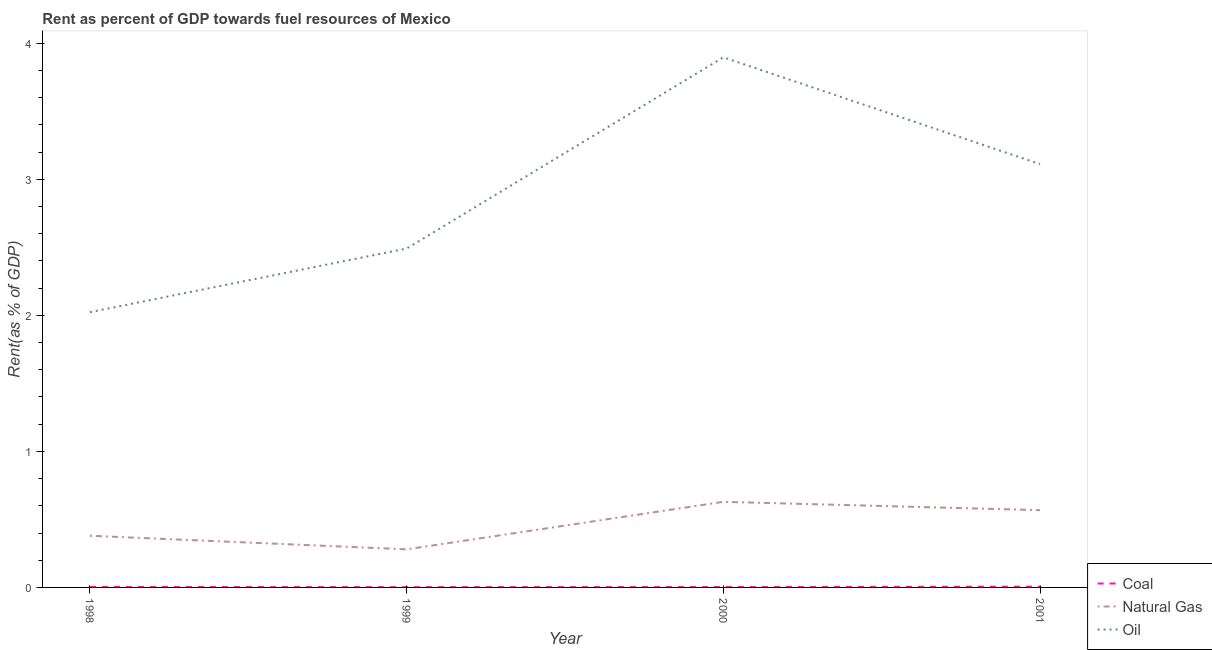Does the line corresponding to rent towards natural gas intersect with the line corresponding to rent towards oil?
Ensure brevity in your answer.  No. What is the rent towards oil in 2001?
Your answer should be very brief. 3.11. Across all years, what is the maximum rent towards oil?
Give a very brief answer. 3.9. Across all years, what is the minimum rent towards oil?
Keep it short and to the point. 2.02. In which year was the rent towards natural gas minimum?
Make the answer very short. 1999. What is the total rent towards coal in the graph?
Give a very brief answer. 0.01. What is the difference between the rent towards coal in 1999 and that in 2001?
Make the answer very short. -0. What is the difference between the rent towards natural gas in 1998 and the rent towards oil in 2000?
Give a very brief answer. -3.52. What is the average rent towards coal per year?
Offer a very short reply. 0. In the year 2000, what is the difference between the rent towards coal and rent towards oil?
Give a very brief answer. -3.89. In how many years, is the rent towards oil greater than 1.6 %?
Offer a very short reply. 4. What is the ratio of the rent towards natural gas in 2000 to that in 2001?
Offer a terse response. 1.11. Is the difference between the rent towards oil in 1998 and 2000 greater than the difference between the rent towards natural gas in 1998 and 2000?
Your answer should be very brief. No. What is the difference between the highest and the second highest rent towards natural gas?
Ensure brevity in your answer.  0.06. What is the difference between the highest and the lowest rent towards natural gas?
Your answer should be compact. 0.35. Is it the case that in every year, the sum of the rent towards coal and rent towards natural gas is greater than the rent towards oil?
Your answer should be very brief. No. Does the rent towards oil monotonically increase over the years?
Your response must be concise. No. Is the rent towards oil strictly less than the rent towards coal over the years?
Offer a terse response. No. How many years are there in the graph?
Keep it short and to the point. 4. Does the graph contain grids?
Provide a short and direct response. No. How many legend labels are there?
Your answer should be very brief. 3. How are the legend labels stacked?
Provide a succinct answer. Vertical. What is the title of the graph?
Ensure brevity in your answer.  Rent as percent of GDP towards fuel resources of Mexico. What is the label or title of the Y-axis?
Make the answer very short. Rent(as % of GDP). What is the Rent(as % of GDP) in Coal in 1998?
Offer a very short reply. 0. What is the Rent(as % of GDP) in Natural Gas in 1998?
Your answer should be very brief. 0.38. What is the Rent(as % of GDP) of Oil in 1998?
Make the answer very short. 2.02. What is the Rent(as % of GDP) of Coal in 1999?
Your answer should be compact. 0. What is the Rent(as % of GDP) of Natural Gas in 1999?
Your response must be concise. 0.28. What is the Rent(as % of GDP) of Oil in 1999?
Offer a terse response. 2.49. What is the Rent(as % of GDP) in Coal in 2000?
Your response must be concise. 0. What is the Rent(as % of GDP) in Natural Gas in 2000?
Ensure brevity in your answer.  0.63. What is the Rent(as % of GDP) of Oil in 2000?
Your answer should be very brief. 3.9. What is the Rent(as % of GDP) in Coal in 2001?
Make the answer very short. 0.01. What is the Rent(as % of GDP) in Natural Gas in 2001?
Your answer should be very brief. 0.57. What is the Rent(as % of GDP) in Oil in 2001?
Give a very brief answer. 3.11. Across all years, what is the maximum Rent(as % of GDP) of Coal?
Give a very brief answer. 0.01. Across all years, what is the maximum Rent(as % of GDP) in Natural Gas?
Ensure brevity in your answer.  0.63. Across all years, what is the maximum Rent(as % of GDP) of Oil?
Keep it short and to the point. 3.9. Across all years, what is the minimum Rent(as % of GDP) of Coal?
Provide a succinct answer. 0. Across all years, what is the minimum Rent(as % of GDP) of Natural Gas?
Keep it short and to the point. 0.28. Across all years, what is the minimum Rent(as % of GDP) in Oil?
Your answer should be very brief. 2.02. What is the total Rent(as % of GDP) of Coal in the graph?
Offer a very short reply. 0.01. What is the total Rent(as % of GDP) in Natural Gas in the graph?
Offer a very short reply. 1.86. What is the total Rent(as % of GDP) of Oil in the graph?
Offer a terse response. 11.52. What is the difference between the Rent(as % of GDP) in Coal in 1998 and that in 1999?
Ensure brevity in your answer.  0. What is the difference between the Rent(as % of GDP) in Natural Gas in 1998 and that in 1999?
Your answer should be very brief. 0.1. What is the difference between the Rent(as % of GDP) of Oil in 1998 and that in 1999?
Your response must be concise. -0.47. What is the difference between the Rent(as % of GDP) in Natural Gas in 1998 and that in 2000?
Offer a terse response. -0.25. What is the difference between the Rent(as % of GDP) of Oil in 1998 and that in 2000?
Your response must be concise. -1.87. What is the difference between the Rent(as % of GDP) in Coal in 1998 and that in 2001?
Make the answer very short. -0. What is the difference between the Rent(as % of GDP) of Natural Gas in 1998 and that in 2001?
Keep it short and to the point. -0.19. What is the difference between the Rent(as % of GDP) in Oil in 1998 and that in 2001?
Your answer should be very brief. -1.09. What is the difference between the Rent(as % of GDP) in Coal in 1999 and that in 2000?
Give a very brief answer. -0. What is the difference between the Rent(as % of GDP) of Natural Gas in 1999 and that in 2000?
Make the answer very short. -0.35. What is the difference between the Rent(as % of GDP) in Oil in 1999 and that in 2000?
Give a very brief answer. -1.41. What is the difference between the Rent(as % of GDP) of Coal in 1999 and that in 2001?
Keep it short and to the point. -0. What is the difference between the Rent(as % of GDP) in Natural Gas in 1999 and that in 2001?
Give a very brief answer. -0.29. What is the difference between the Rent(as % of GDP) in Oil in 1999 and that in 2001?
Provide a short and direct response. -0.62. What is the difference between the Rent(as % of GDP) in Coal in 2000 and that in 2001?
Keep it short and to the point. -0. What is the difference between the Rent(as % of GDP) in Natural Gas in 2000 and that in 2001?
Provide a succinct answer. 0.06. What is the difference between the Rent(as % of GDP) in Oil in 2000 and that in 2001?
Provide a short and direct response. 0.78. What is the difference between the Rent(as % of GDP) of Coal in 1998 and the Rent(as % of GDP) of Natural Gas in 1999?
Make the answer very short. -0.28. What is the difference between the Rent(as % of GDP) in Coal in 1998 and the Rent(as % of GDP) in Oil in 1999?
Your answer should be compact. -2.49. What is the difference between the Rent(as % of GDP) in Natural Gas in 1998 and the Rent(as % of GDP) in Oil in 1999?
Give a very brief answer. -2.11. What is the difference between the Rent(as % of GDP) of Coal in 1998 and the Rent(as % of GDP) of Natural Gas in 2000?
Your answer should be compact. -0.63. What is the difference between the Rent(as % of GDP) in Coal in 1998 and the Rent(as % of GDP) in Oil in 2000?
Keep it short and to the point. -3.89. What is the difference between the Rent(as % of GDP) in Natural Gas in 1998 and the Rent(as % of GDP) in Oil in 2000?
Provide a succinct answer. -3.52. What is the difference between the Rent(as % of GDP) in Coal in 1998 and the Rent(as % of GDP) in Natural Gas in 2001?
Make the answer very short. -0.56. What is the difference between the Rent(as % of GDP) of Coal in 1998 and the Rent(as % of GDP) of Oil in 2001?
Provide a succinct answer. -3.11. What is the difference between the Rent(as % of GDP) of Natural Gas in 1998 and the Rent(as % of GDP) of Oil in 2001?
Your answer should be very brief. -2.73. What is the difference between the Rent(as % of GDP) of Coal in 1999 and the Rent(as % of GDP) of Natural Gas in 2000?
Give a very brief answer. -0.63. What is the difference between the Rent(as % of GDP) in Coal in 1999 and the Rent(as % of GDP) in Oil in 2000?
Make the answer very short. -3.89. What is the difference between the Rent(as % of GDP) of Natural Gas in 1999 and the Rent(as % of GDP) of Oil in 2000?
Give a very brief answer. -3.62. What is the difference between the Rent(as % of GDP) in Coal in 1999 and the Rent(as % of GDP) in Natural Gas in 2001?
Make the answer very short. -0.57. What is the difference between the Rent(as % of GDP) of Coal in 1999 and the Rent(as % of GDP) of Oil in 2001?
Keep it short and to the point. -3.11. What is the difference between the Rent(as % of GDP) of Natural Gas in 1999 and the Rent(as % of GDP) of Oil in 2001?
Provide a short and direct response. -2.83. What is the difference between the Rent(as % of GDP) of Coal in 2000 and the Rent(as % of GDP) of Natural Gas in 2001?
Your answer should be very brief. -0.57. What is the difference between the Rent(as % of GDP) in Coal in 2000 and the Rent(as % of GDP) in Oil in 2001?
Your answer should be compact. -3.11. What is the difference between the Rent(as % of GDP) of Natural Gas in 2000 and the Rent(as % of GDP) of Oil in 2001?
Ensure brevity in your answer.  -2.48. What is the average Rent(as % of GDP) of Coal per year?
Ensure brevity in your answer.  0. What is the average Rent(as % of GDP) in Natural Gas per year?
Give a very brief answer. 0.46. What is the average Rent(as % of GDP) in Oil per year?
Your answer should be very brief. 2.88. In the year 1998, what is the difference between the Rent(as % of GDP) in Coal and Rent(as % of GDP) in Natural Gas?
Ensure brevity in your answer.  -0.38. In the year 1998, what is the difference between the Rent(as % of GDP) in Coal and Rent(as % of GDP) in Oil?
Your answer should be very brief. -2.02. In the year 1998, what is the difference between the Rent(as % of GDP) in Natural Gas and Rent(as % of GDP) in Oil?
Ensure brevity in your answer.  -1.64. In the year 1999, what is the difference between the Rent(as % of GDP) of Coal and Rent(as % of GDP) of Natural Gas?
Keep it short and to the point. -0.28. In the year 1999, what is the difference between the Rent(as % of GDP) in Coal and Rent(as % of GDP) in Oil?
Make the answer very short. -2.49. In the year 1999, what is the difference between the Rent(as % of GDP) of Natural Gas and Rent(as % of GDP) of Oil?
Provide a short and direct response. -2.21. In the year 2000, what is the difference between the Rent(as % of GDP) of Coal and Rent(as % of GDP) of Natural Gas?
Your answer should be very brief. -0.63. In the year 2000, what is the difference between the Rent(as % of GDP) in Coal and Rent(as % of GDP) in Oil?
Your answer should be compact. -3.89. In the year 2000, what is the difference between the Rent(as % of GDP) of Natural Gas and Rent(as % of GDP) of Oil?
Make the answer very short. -3.27. In the year 2001, what is the difference between the Rent(as % of GDP) in Coal and Rent(as % of GDP) in Natural Gas?
Provide a short and direct response. -0.56. In the year 2001, what is the difference between the Rent(as % of GDP) in Coal and Rent(as % of GDP) in Oil?
Make the answer very short. -3.11. In the year 2001, what is the difference between the Rent(as % of GDP) in Natural Gas and Rent(as % of GDP) in Oil?
Keep it short and to the point. -2.54. What is the ratio of the Rent(as % of GDP) of Coal in 1998 to that in 1999?
Keep it short and to the point. 1.87. What is the ratio of the Rent(as % of GDP) in Natural Gas in 1998 to that in 1999?
Give a very brief answer. 1.36. What is the ratio of the Rent(as % of GDP) in Oil in 1998 to that in 1999?
Provide a succinct answer. 0.81. What is the ratio of the Rent(as % of GDP) in Coal in 1998 to that in 2000?
Ensure brevity in your answer.  1.35. What is the ratio of the Rent(as % of GDP) in Natural Gas in 1998 to that in 2000?
Give a very brief answer. 0.6. What is the ratio of the Rent(as % of GDP) of Oil in 1998 to that in 2000?
Your response must be concise. 0.52. What is the ratio of the Rent(as % of GDP) in Coal in 1998 to that in 2001?
Provide a short and direct response. 0.67. What is the ratio of the Rent(as % of GDP) of Natural Gas in 1998 to that in 2001?
Keep it short and to the point. 0.67. What is the ratio of the Rent(as % of GDP) of Oil in 1998 to that in 2001?
Your response must be concise. 0.65. What is the ratio of the Rent(as % of GDP) of Coal in 1999 to that in 2000?
Keep it short and to the point. 0.72. What is the ratio of the Rent(as % of GDP) in Natural Gas in 1999 to that in 2000?
Provide a succinct answer. 0.45. What is the ratio of the Rent(as % of GDP) of Oil in 1999 to that in 2000?
Your response must be concise. 0.64. What is the ratio of the Rent(as % of GDP) in Coal in 1999 to that in 2001?
Make the answer very short. 0.36. What is the ratio of the Rent(as % of GDP) in Natural Gas in 1999 to that in 2001?
Give a very brief answer. 0.49. What is the ratio of the Rent(as % of GDP) in Oil in 1999 to that in 2001?
Your answer should be very brief. 0.8. What is the ratio of the Rent(as % of GDP) of Coal in 2000 to that in 2001?
Your answer should be very brief. 0.5. What is the ratio of the Rent(as % of GDP) of Natural Gas in 2000 to that in 2001?
Make the answer very short. 1.11. What is the ratio of the Rent(as % of GDP) of Oil in 2000 to that in 2001?
Your answer should be compact. 1.25. What is the difference between the highest and the second highest Rent(as % of GDP) in Coal?
Provide a short and direct response. 0. What is the difference between the highest and the second highest Rent(as % of GDP) of Natural Gas?
Offer a very short reply. 0.06. What is the difference between the highest and the second highest Rent(as % of GDP) in Oil?
Give a very brief answer. 0.78. What is the difference between the highest and the lowest Rent(as % of GDP) of Coal?
Make the answer very short. 0. What is the difference between the highest and the lowest Rent(as % of GDP) of Natural Gas?
Your answer should be very brief. 0.35. What is the difference between the highest and the lowest Rent(as % of GDP) of Oil?
Offer a terse response. 1.87. 